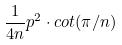Convert formula to latex. <formula><loc_0><loc_0><loc_500><loc_500>\frac { 1 } { 4 n } p ^ { 2 } \cdot c o t ( \pi / n )</formula> 